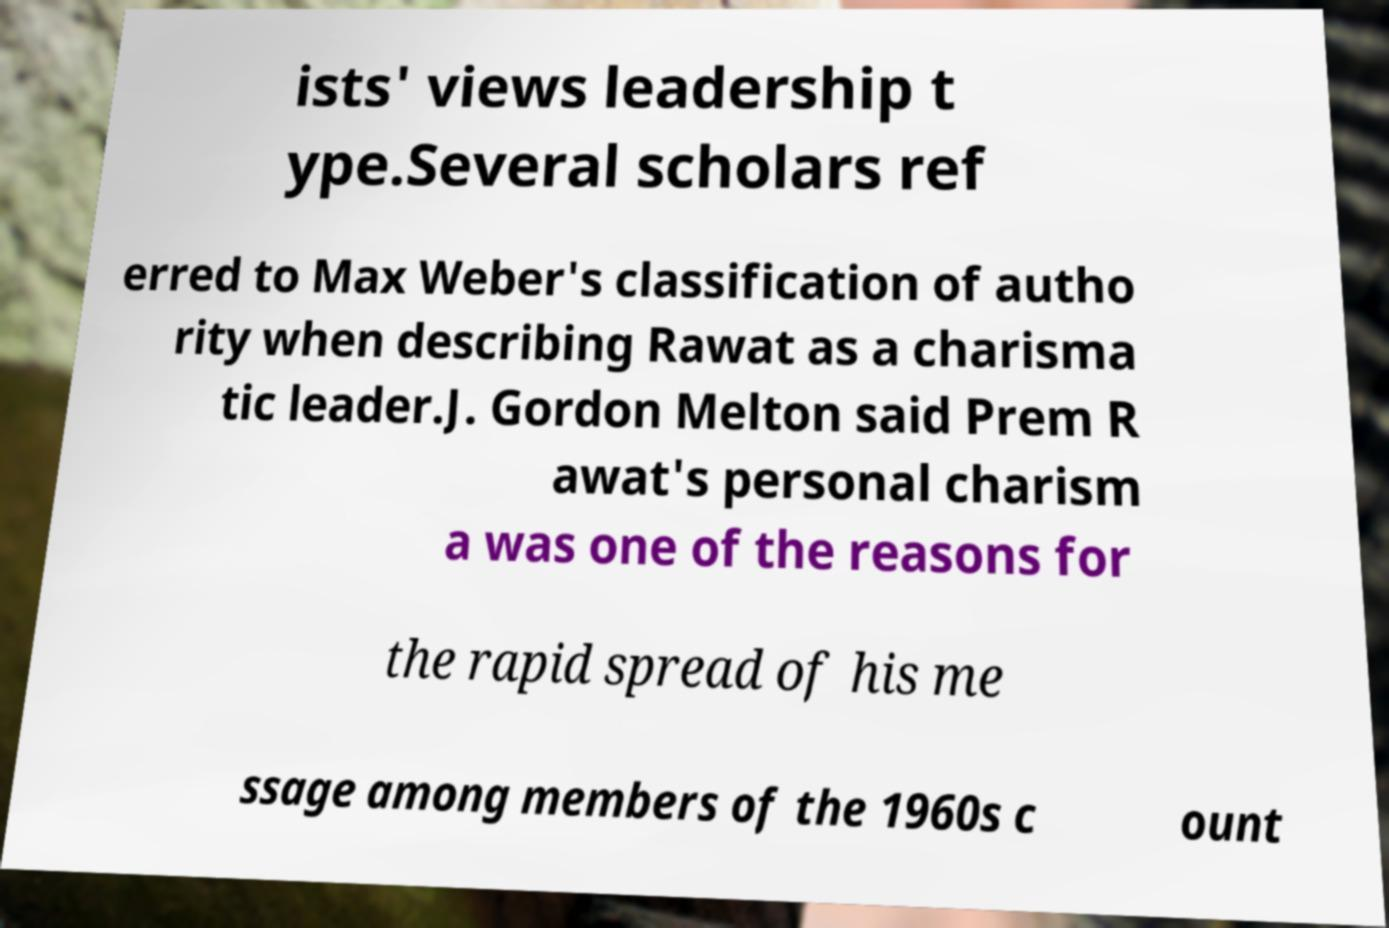I need the written content from this picture converted into text. Can you do that? ists' views leadership t ype.Several scholars ref erred to Max Weber's classification of autho rity when describing Rawat as a charisma tic leader.J. Gordon Melton said Prem R awat's personal charism a was one of the reasons for the rapid spread of his me ssage among members of the 1960s c ount 